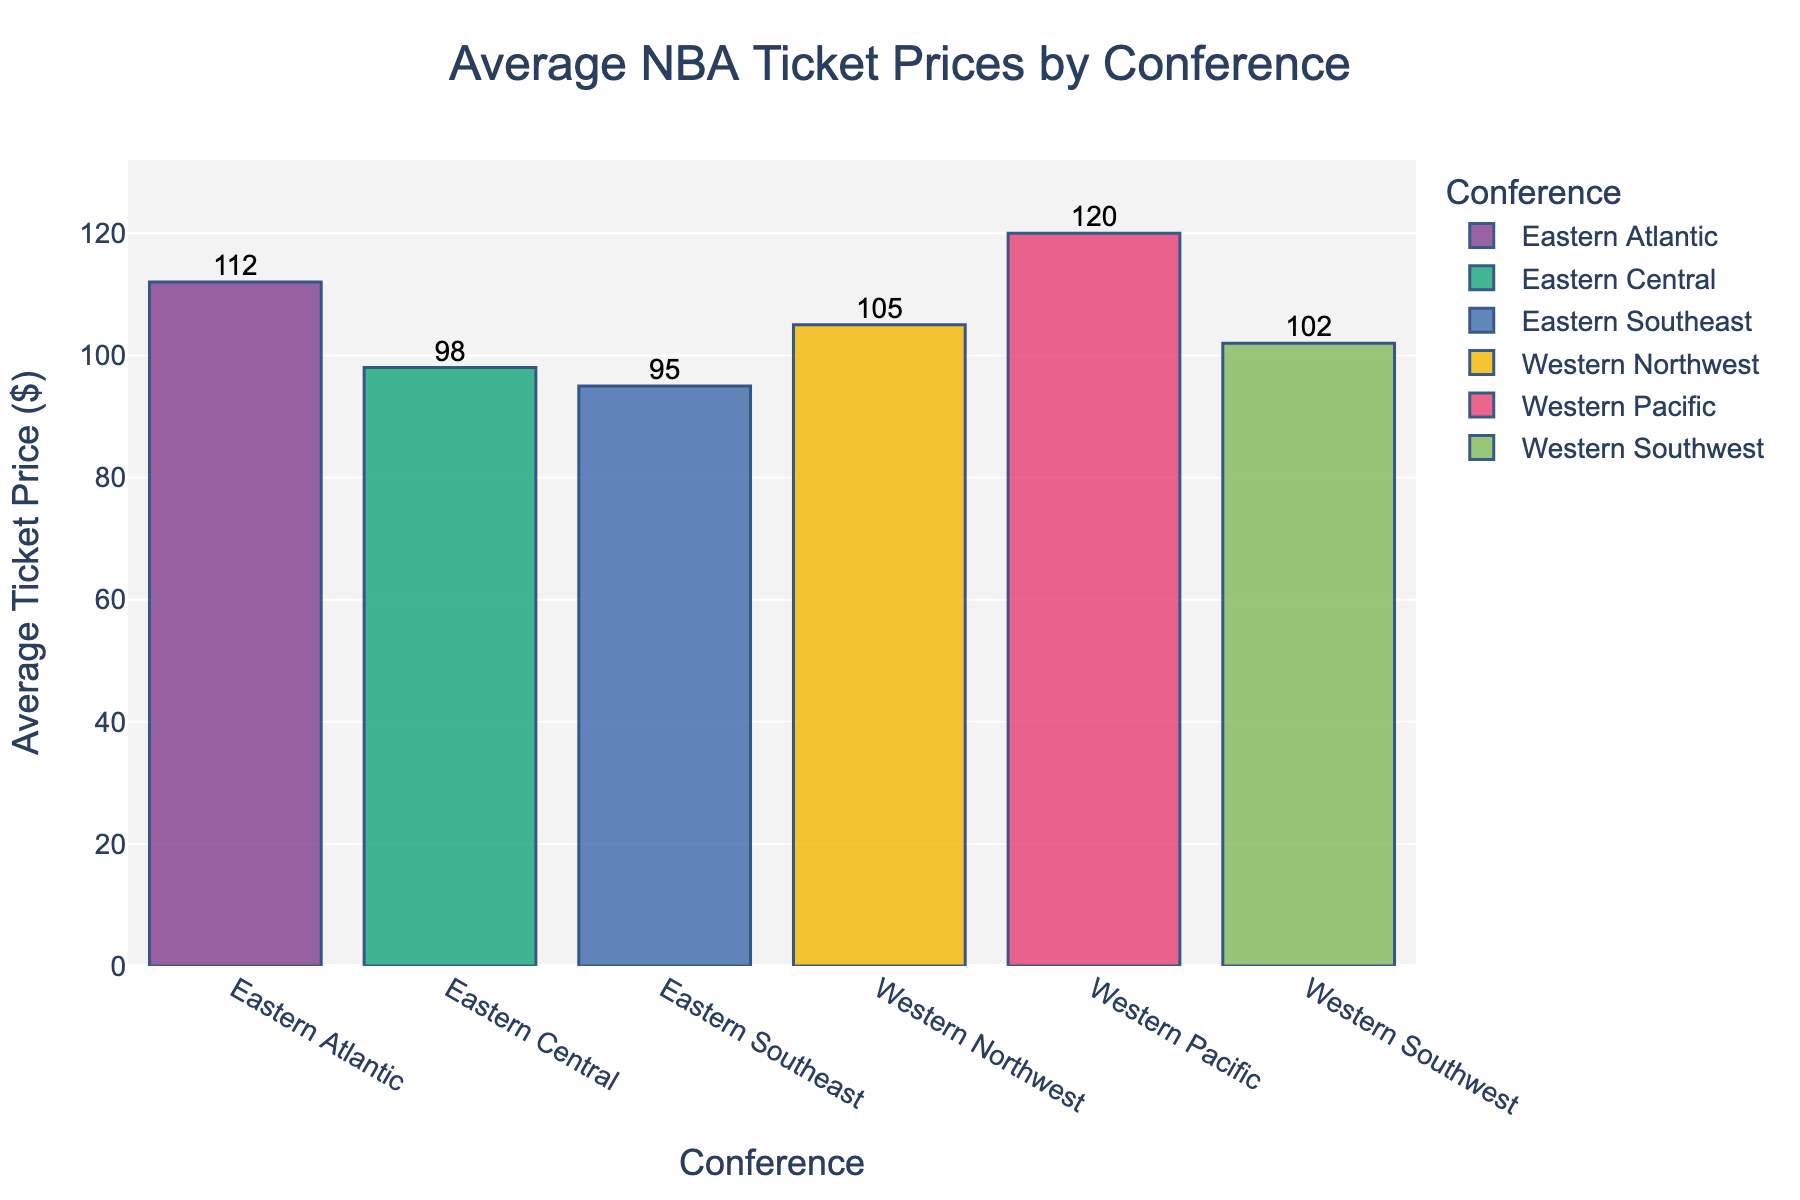What's the conference with the highest average ticket price? Look at the bar representing the average ticket price for each conference. The Western Pacific Conference has the tallest bar.
Answer: Western Pacific Which conference has the lowest average ticket price, and what is that price? Compare the height of all the bars. The Eastern Southeast Conference has the shortest bar, and the corresponding label on top of the bar shows $95.
Answer: Eastern Southeast, $95 What is the average ticket price difference between the Western Pacific and Eastern Atlantic conferences? The Western Pacific has an average ticket price of $120, and the Eastern Atlantic has $112. Subtract $112 from $120 to get the difference.
Answer: $8 What's the sum of the average ticket prices for all conferences? Add up the values: $112 (Eastern Atlantic) + $98 (Eastern Central) + $95 (Eastern Southeast) + $105 (Western Northwest) + $120 (Western Pacific) + $102 (Western Southwest) = $632.
Answer: $632 Which conference has an average ticket price that is $7 more than the Western Southwest conference? The Western Southwest conference has an average ticket price of $102. Adding $7 gives $109. No conference matches exactly $109, so this scenario does not occur in the data presented.
Answer: None Are there more conferences with average ticket prices above $100 or below $100? Count the conferences with prices above $100 (Eastern Atlantic, Western Northwest, Western Pacific, Western Southwest) and those below $100 (Eastern Central, Eastern Southeast).
Answer: Above $100 What is the difference in average ticket price between the highest and lowest-priced conferences? The highest average ticket price is $120 (Western Pacific), and the lowest is $95 (Eastern Southeast). Subtract $95 from $120.
Answer: $25 Which conference has an average ticket price closest to $100? Compare $100 with the average ticket prices of each conference. The Eastern Central conference has an average ticket price of $98, which is closest to $100.
Answer: Eastern Central In terms of ticket prices, which conference, Eastern or Western, is more expensive on average? Calculate the average of the ticket prices for Eastern (112, 98, 95) and Western (105, 120, 102) conferences. Sum of Eastern is 305, average is 305/3 = ~101.67. Sum of Western is 327, average is 327/3 = ~109.
Answer: Western How much more expensive is the average ticket price in the Western Pacific compared to the Western Southwest? The Western Pacific average ticket price is $120, and the Western Southwest is $102. Subtract $102 from $120.
Answer: $18 